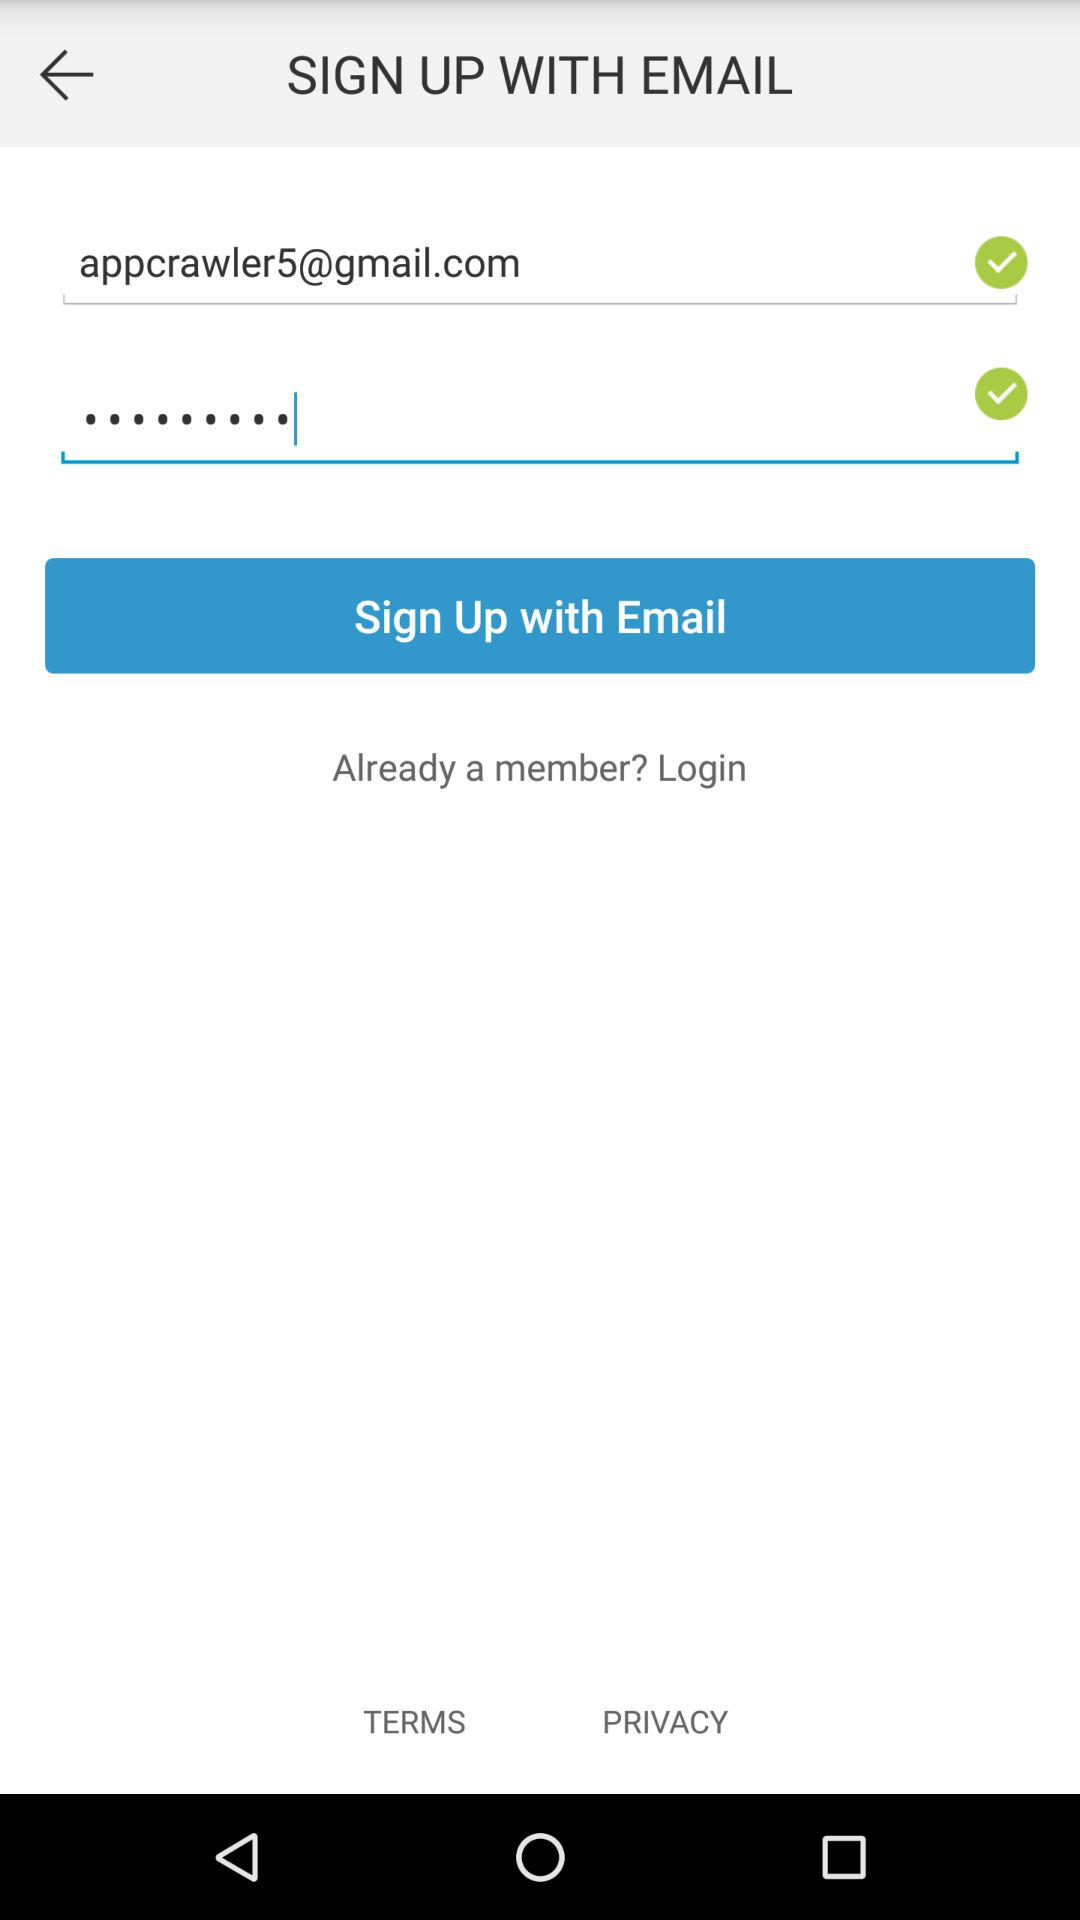What Gmail address can be used to sign up? The Gmail address that can be used to sign up is appcrawler5@gmail.com. 